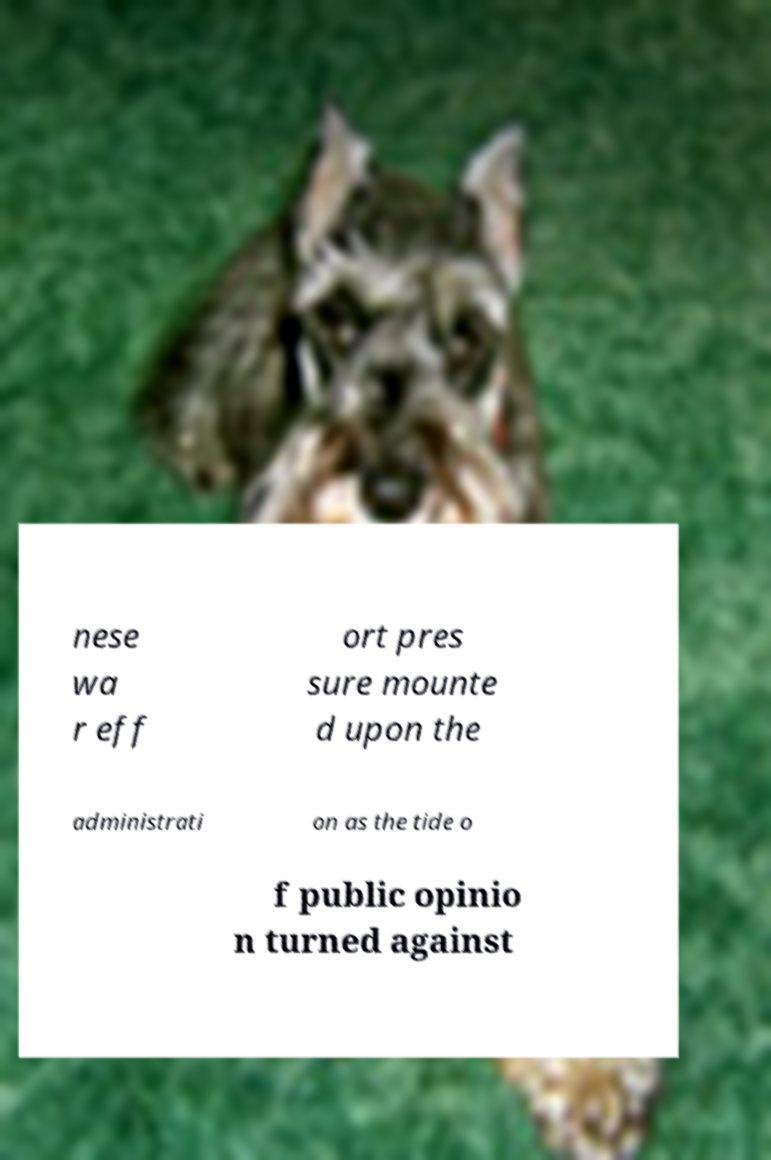Please identify and transcribe the text found in this image. nese wa r eff ort pres sure mounte d upon the administrati on as the tide o f public opinio n turned against 